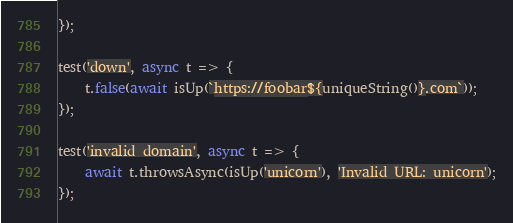<code> <loc_0><loc_0><loc_500><loc_500><_JavaScript_>});

test('down', async t => {
	t.false(await isUp(`https://foobar${uniqueString()}.com`));
});

test('invalid domain', async t => {
	await t.throwsAsync(isUp('unicorn'), 'Invalid URL: unicorn');
});
</code> 